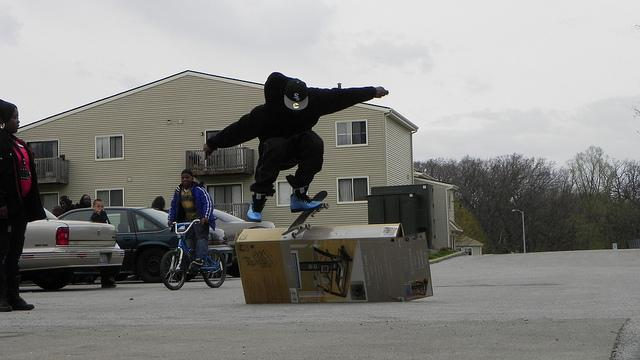What is the average size of skateboard?

Choices:
A) 9inches
B) 12inches
C) 15inches
D) 8inches 8inches 